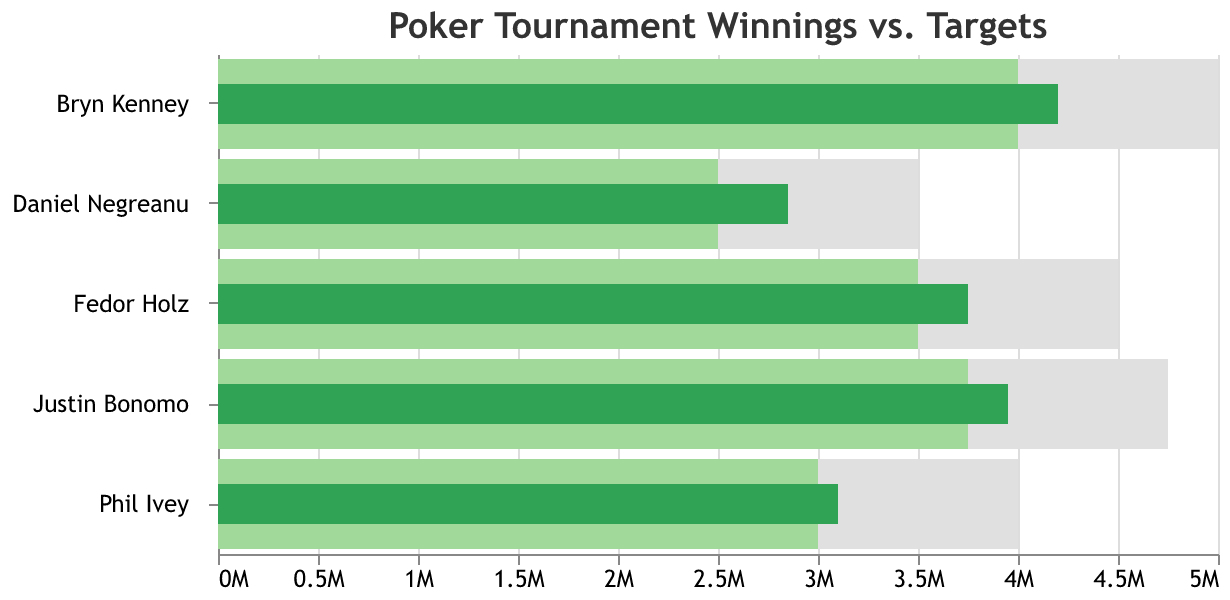What's the title of the figure? The title of the figure is displayed prominently at the top and is "Poker Tournament Winnings vs. Targets".
Answer: Poker Tournament Winnings vs. Targets How many players are represented in the figure? By looking at the Y-axis, which shows the different players' names, we can count there are 5 players represented: Daniel Negreanu, Phil Ivey, Fedor Holz, Bryn Kenney, Justin Bonomo.
Answer: 5 Which player has the highest actual winnings? The bar representing actual winnings is shown in dark green. The player with the longest dark green bar is Bryn Kenney.
Answer: Bryn Kenney By how much did Justin Bonomo exceed his target winnings? Justin Bonomo's actual winnings (39,50,000 USD) and target winnings (37,50,000 USD) are represented by the dark green and light green bars, respectively. The difference is 39,50,000 - 37,50,000.
Answer: 2,00,000 USD Which player had the smallest margin between their actual winnings and the maximum limit? To find this, we'll look at the dark green (actual winnings) and grey (maximum) bars. The smallest difference is for Phil Ivey, where the maximum is 40,00,000 and the actual winnings are 31,00,000, a margin of 9,00,000.
Answer: Phil Ivey Did Fedor Holz meet his target winnings? We check if the dark green bar (actual winnings) meets or exceeds the light green bar (target). For Fedor Holz, actual winnings (37,50,000) did exceed the target (35,00,000).
Answer: Yes Arrange the players in descending order based on their target winnings. Checking the light green bars for each player, we list them from highest to lowest: Bryn Kenney, Justin Bonomo, Fedor Holz, Phil Ivey, Daniel Negreanu.
Answer: Bryn Kenney, Justin Bonomo, Fedor Holz, Phil Ivey, Daniel Negreanu What is the average of the maximum winnings across all players? Sum up all players' maximum winnings: 35,00,000 (Negreanu) + 40,00,000 (Ivey) + 45,00,000 (Holz) + 50,00,000 (Kenney) + 47,50,000 (Bonomo), totaling 2,17,50,000. Divide by the number of players 2,17,50,000 / 5.
Answer: 43,50,000 USD What is the difference in actual winnings between the top two players? Bryn Kenney and Justin Bonomo have the highest actual winnings with 42,00,000 and 39,50,000 respectively. The difference is 42,00,000 - 39,50,000.
Answer: 2,50,000 USD 